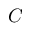<formula> <loc_0><loc_0><loc_500><loc_500>C</formula> 